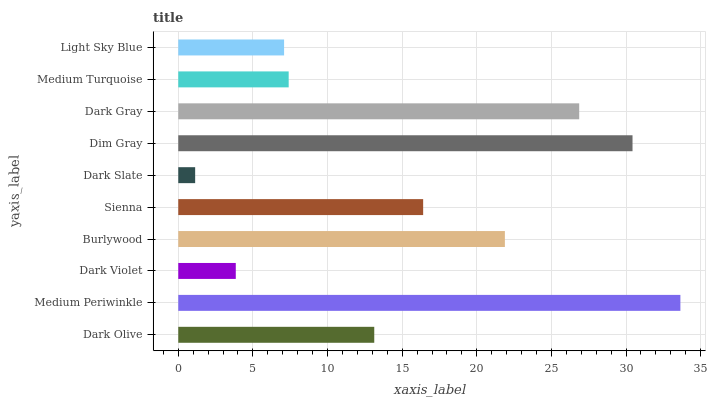Is Dark Slate the minimum?
Answer yes or no. Yes. Is Medium Periwinkle the maximum?
Answer yes or no. Yes. Is Dark Violet the minimum?
Answer yes or no. No. Is Dark Violet the maximum?
Answer yes or no. No. Is Medium Periwinkle greater than Dark Violet?
Answer yes or no. Yes. Is Dark Violet less than Medium Periwinkle?
Answer yes or no. Yes. Is Dark Violet greater than Medium Periwinkle?
Answer yes or no. No. Is Medium Periwinkle less than Dark Violet?
Answer yes or no. No. Is Sienna the high median?
Answer yes or no. Yes. Is Dark Olive the low median?
Answer yes or no. Yes. Is Dark Violet the high median?
Answer yes or no. No. Is Sienna the low median?
Answer yes or no. No. 